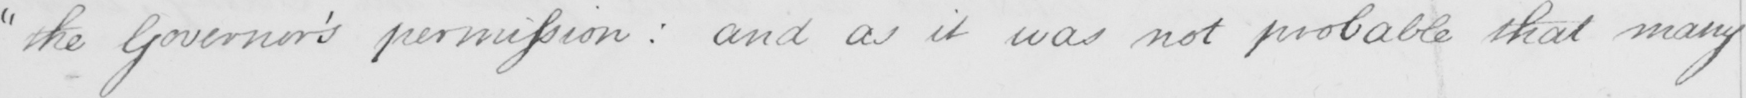Can you tell me what this handwritten text says? " the Governor ' s permission :  and as it was not probable that many 